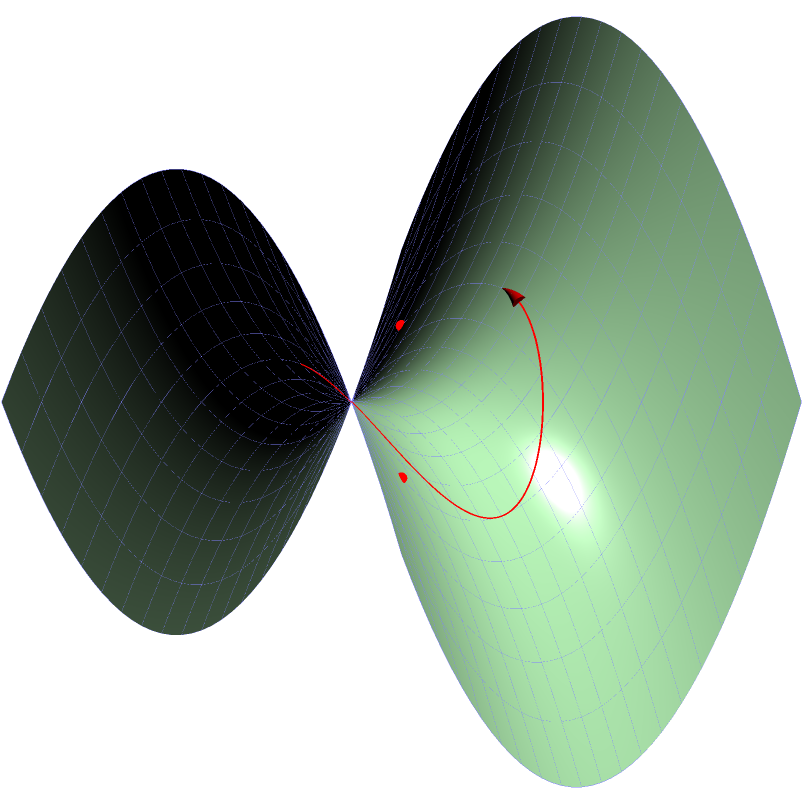On a saddle-shaped surface described by the equation $z = x^2 - y^2$, what is the general shape of the shortest path (geodesic) between the points $(1,1,0)$ and $(-1,-1,0)$? How does this differ from the shortest path on a flat plane? To understand the geodesic on this saddle-shaped surface, let's follow these steps:

1) First, recall that on a flat plane, the shortest path between two points is always a straight line.

2) However, on a curved surface like our saddle, the geodesic (shortest path) is influenced by the curvature of the surface.

3) The saddle surface is described by $z = x^2 - y^2$. This creates a surface that curves upward along the x-axis and downward along the y-axis.

4) The two points in question, $(1,1,0)$ and $(-1,-1,0)$, lie on opposite corners of this saddle.

5) If we were to "flatten" this surface, the geodesic would appear curved, bending away from the y-axis and towards the x-axis.

6) This is because the path tries to minimize its length by taking advantage of the surface's curvature. It "climbs" less steeply than a straight line would.

7) The actual geodesic on this surface would be a curve that starts at $(1,1,0)$, bends towards the x-axis, crosses the y=x line at some point, and then curves back to reach $(-1,-1,0)$.

8) This curved path is shorter on the saddle surface than a "straight" line would be, even though it looks longer when viewed from above.

Therefore, the geodesic on this saddle surface is a curved path that bends towards the x-axis, in contrast to the straight line that would be the shortest path on a flat plane.
Answer: Curved path bending towards x-axis 